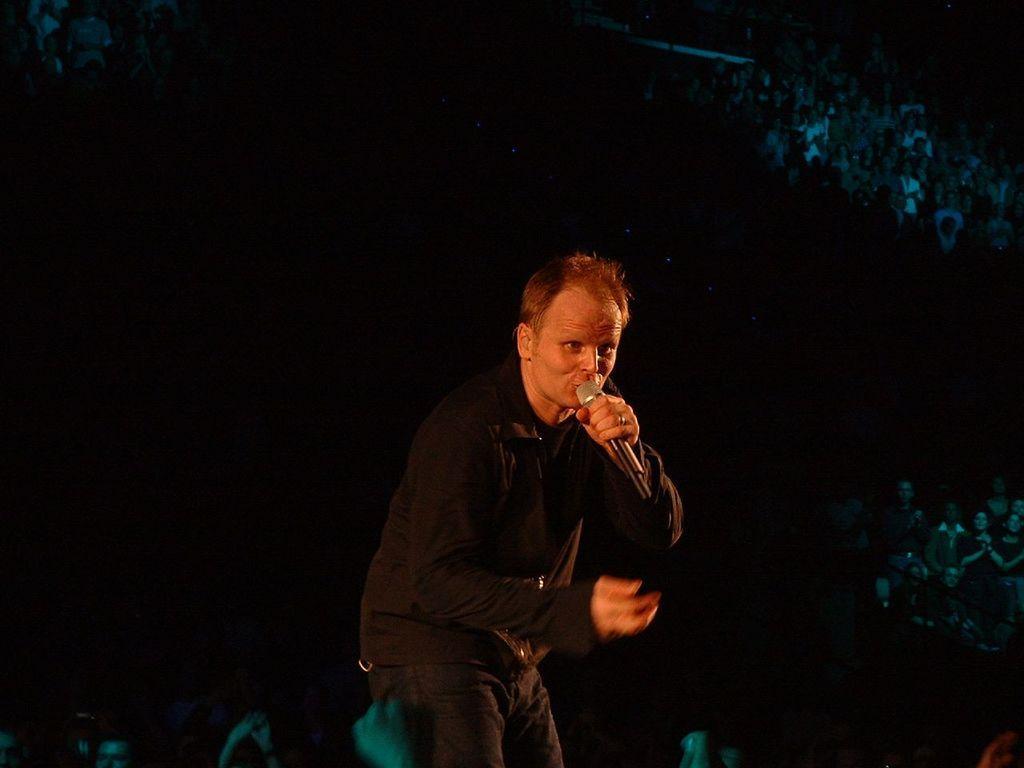How would you summarize this image in a sentence or two? A man is standing and singing in the microphone. 